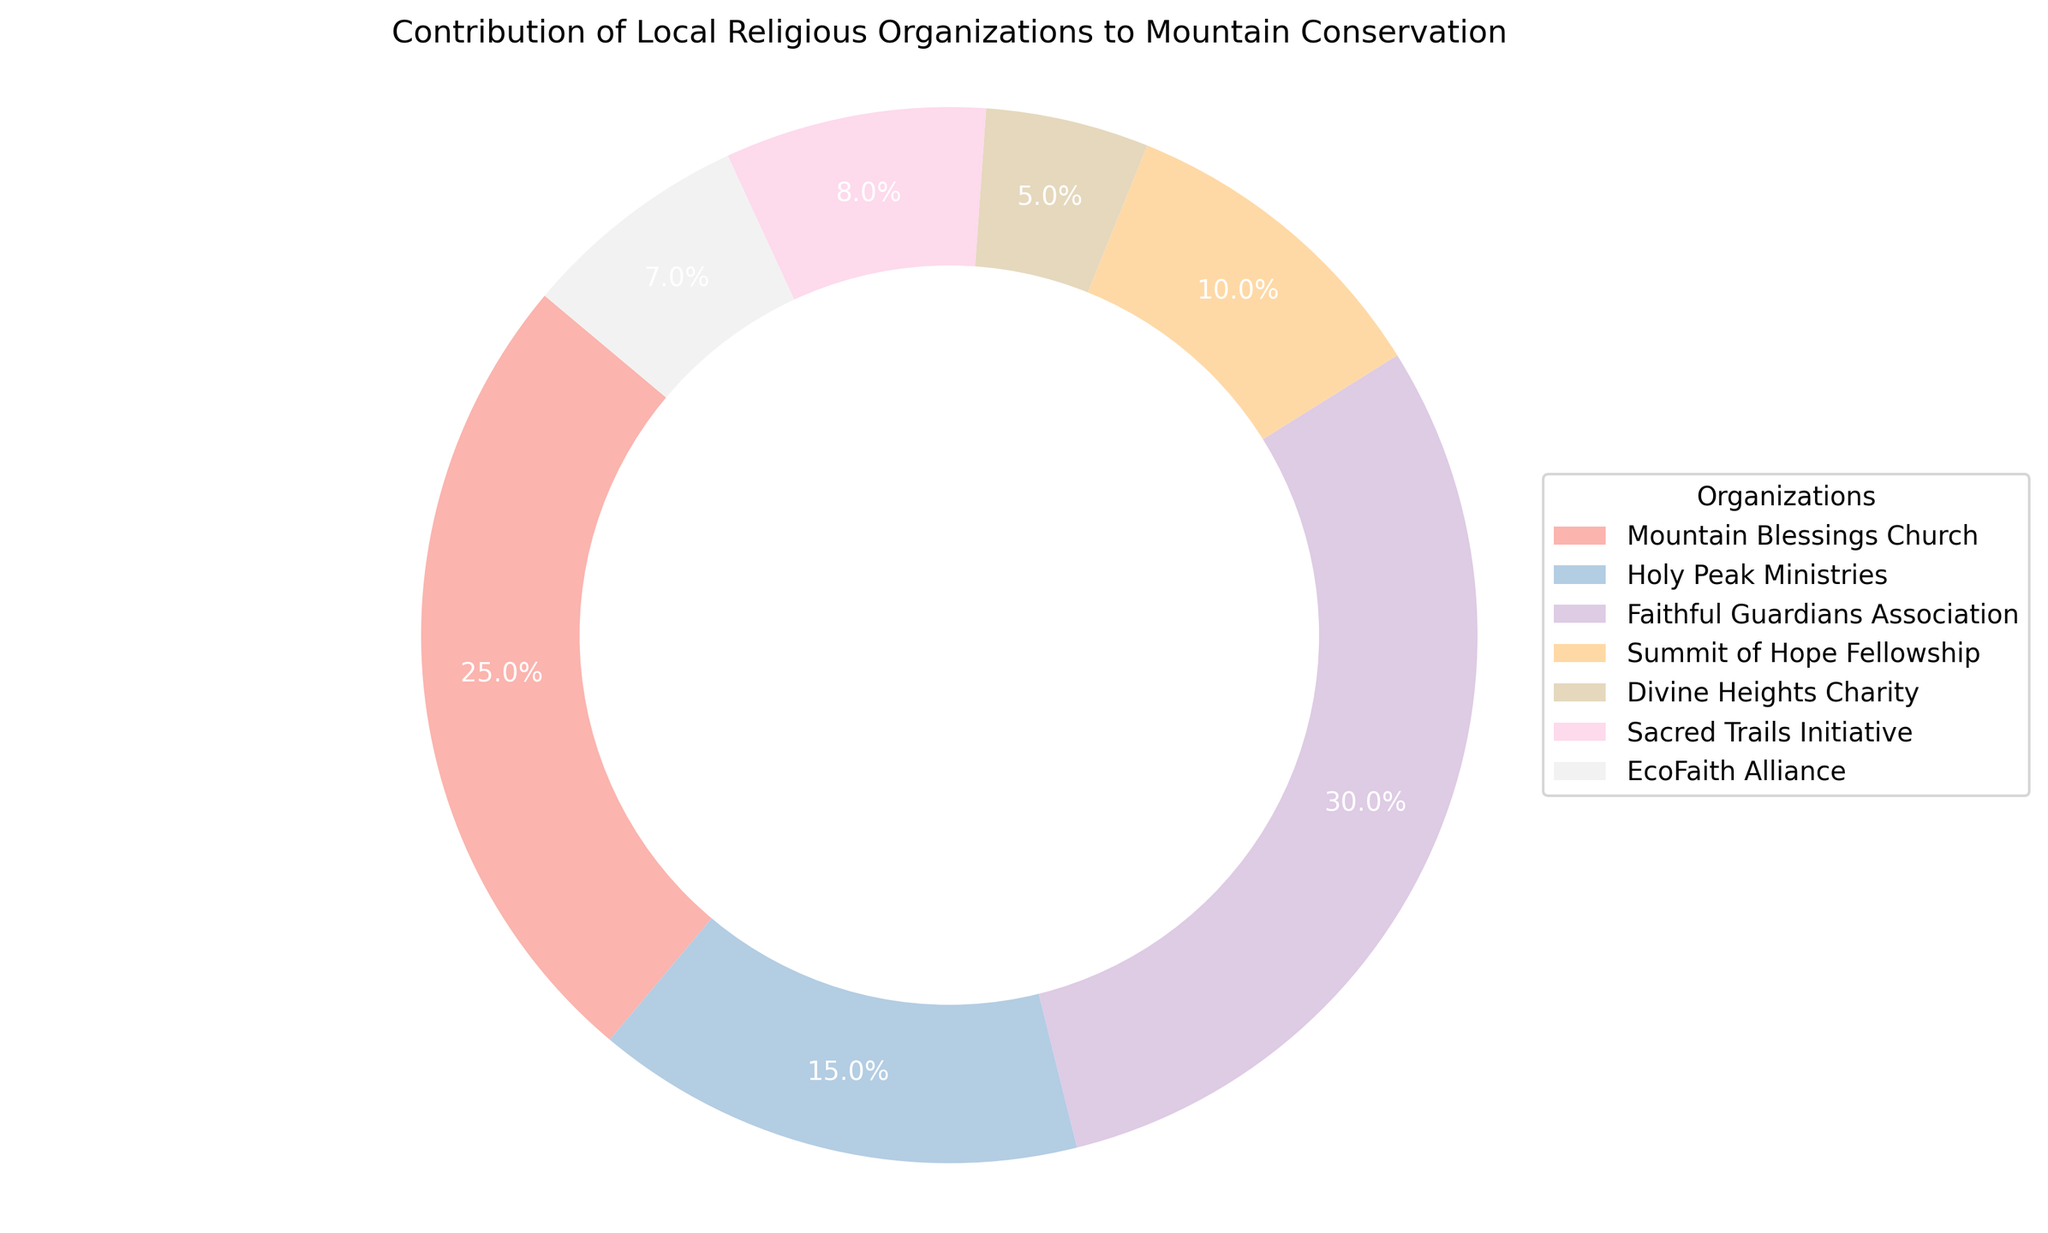Which organization contributed the most to mountain conservation efforts? By looking at the pie chart, the largest segment can be identified, which is labeled as "Faithful Guardians Association" with a 30% contribution.
Answer: Faithful Guardians Association Which two organizations have the smallest contributions combined? Identify the two smallest slices in the pie chart. "Divine Heights Charity" with 5% and "EcoFaith Alliance" with 7% combined to be 12%.
Answer: Divine Heights Charity and EcoFaith Alliance What is the difference in contribution percentages between "Summit of Hope Fellowship" and "Holy Peak Ministries"? From the pie chart, "Summit of Hope Fellowship" contributed 10% and "Holy Peak Ministries" 15%. The difference is 15% - 10% = 5%.
Answer: 5% Which organization has a larger contribution: "Sacred Trails Initiative" or "Mountain Blessings Church"? Comparing the segments in the pie chart, "Mountain Blessings Church" contributed 25% and "Sacred Trails Initiative" contributed 8%.
Answer: Mountain Blessings Church What is the total percentage contribution from "Mountain Blessings Church" and "Faithful Guardians Association"? Add the percentages of "Mountain Blessings Church" (25%) and "Faithful Guardians Association" (30%). The total is 25% + 30% = 55%.
Answer: 55% Which organizations contribute more than 10%? Any segment in the pie chart larger than 10% qualifies. These are: "Mountain Blessings Church" (25%), "Faithful Guardians Association" (30%), and "Holy Peak Ministries" (15%).
Answer: Mountain Blessings Church, Faithful Guardians Association, Holy Peak Ministries What proportion of the total contributions is made by "Sacred Trails Initiative"? Look at the "Sacred Trails Initiative" segment in the pie chart, labeled as 8%.
Answer: 8% How many organizations contributed less than 10%? Count the segments in the pie chart with a contribution below 10%. These are: "Summit of Hope Fellowship" (10%), "Divine Heights Charity" (5%), "Sacred Trails Initiative" (8%), and "EcoFaith Alliance" (7%). A total of 4 organizations.
Answer: 4 Is "Holy Peak Ministries" contribution more or less than "Summit of Hope Fellowship" plus "Divine Heights Charity"? "Holy Peak Ministries" contribution is 15%. "Summit of Hope Fellowship" plus "Divine Heights Charity" is 10% + 5% = 15%. The contributions are equal.
Answer: Equal Which organization's contribution is represented by the darkest color in the pie chart? From the color distribution in the pie chart generated using Pastel1 colormap, the darkest color segment corresponds to "Faithful Guardians Association"
Answer: Faithful Guardians Association 